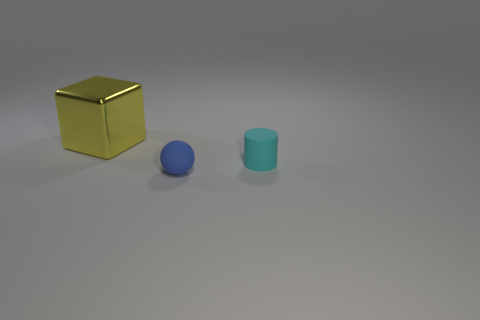Add 1 big spheres. How many objects exist? 4 Subtract all balls. How many objects are left? 2 Add 3 big brown things. How many big brown things exist? 3 Subtract 0 yellow cylinders. How many objects are left? 3 Subtract all big yellow things. Subtract all tiny cyan things. How many objects are left? 1 Add 1 small cyan rubber things. How many small cyan rubber things are left? 2 